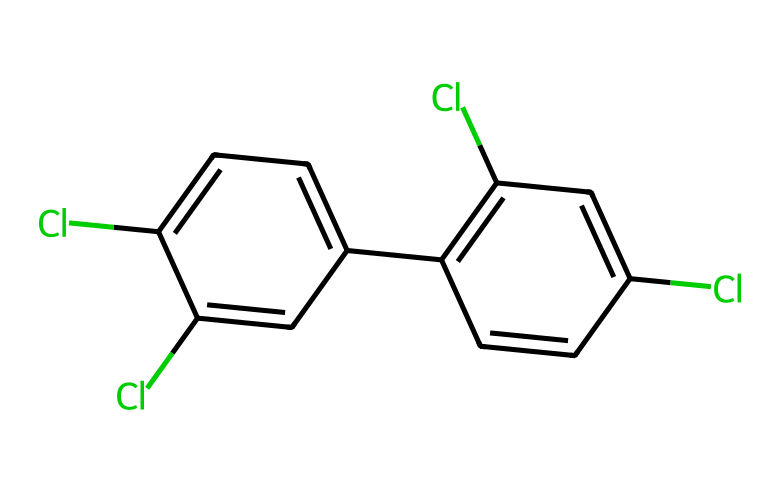How many chlorine atoms are present in this chemical? By analyzing the SMILES representation, we can see that there are four occurrences of "Cl", indicating that four chlorine atoms are attached to the biphenyl structure.
Answer: four What is the base structure of this molecule? The molecule's structure indicates the presence of two connected benzene rings, which together form a biphenyl core. The biphenyl structure is recognizable from the arrangement of carbon atoms and the fused aromatic character.
Answer: biphenyl What is the total number of carbon atoms in this chemical? The chemical structure contains ten carbon atoms, counted from the biphenyl core and not including any hydrogen or chlorine atoms. Each benzene ring typically has six carbon atoms, but due to the connection of the rings, two are shared. Thus, 6 + 6 - 2 = 10.
Answer: ten Is this chemical classified as a persistent organic pollutant? Yes, PCBs are classified as persistent organic pollutants due to their stable, resistant nature to environmental degradation, which results from the presence of multiple chlorine atoms in their structure.
Answer: yes What property relates to the toxicity of this chemical? The presence of chlorine atoms contributes to the hydrophobic nature of the molecule, enhancing its bioaccumulation in living organisms and thus relating to its toxic properties.
Answer: hydrophobicity 